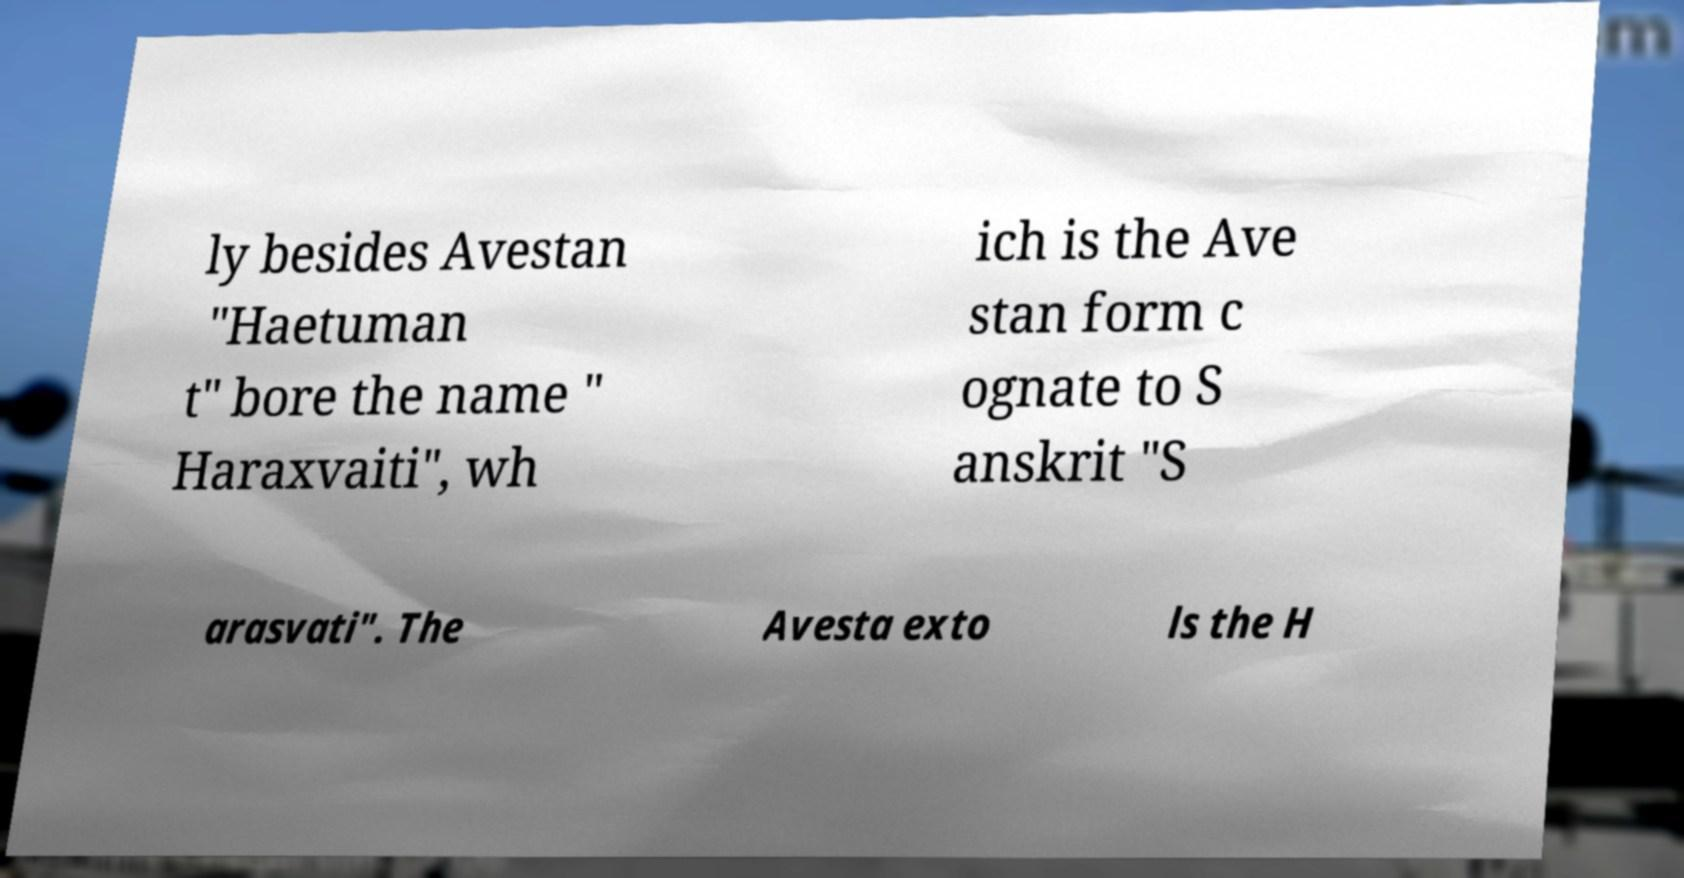Can you read and provide the text displayed in the image?This photo seems to have some interesting text. Can you extract and type it out for me? ly besides Avestan "Haetuman t" bore the name " Haraxvaiti", wh ich is the Ave stan form c ognate to S anskrit "S arasvati". The Avesta exto ls the H 